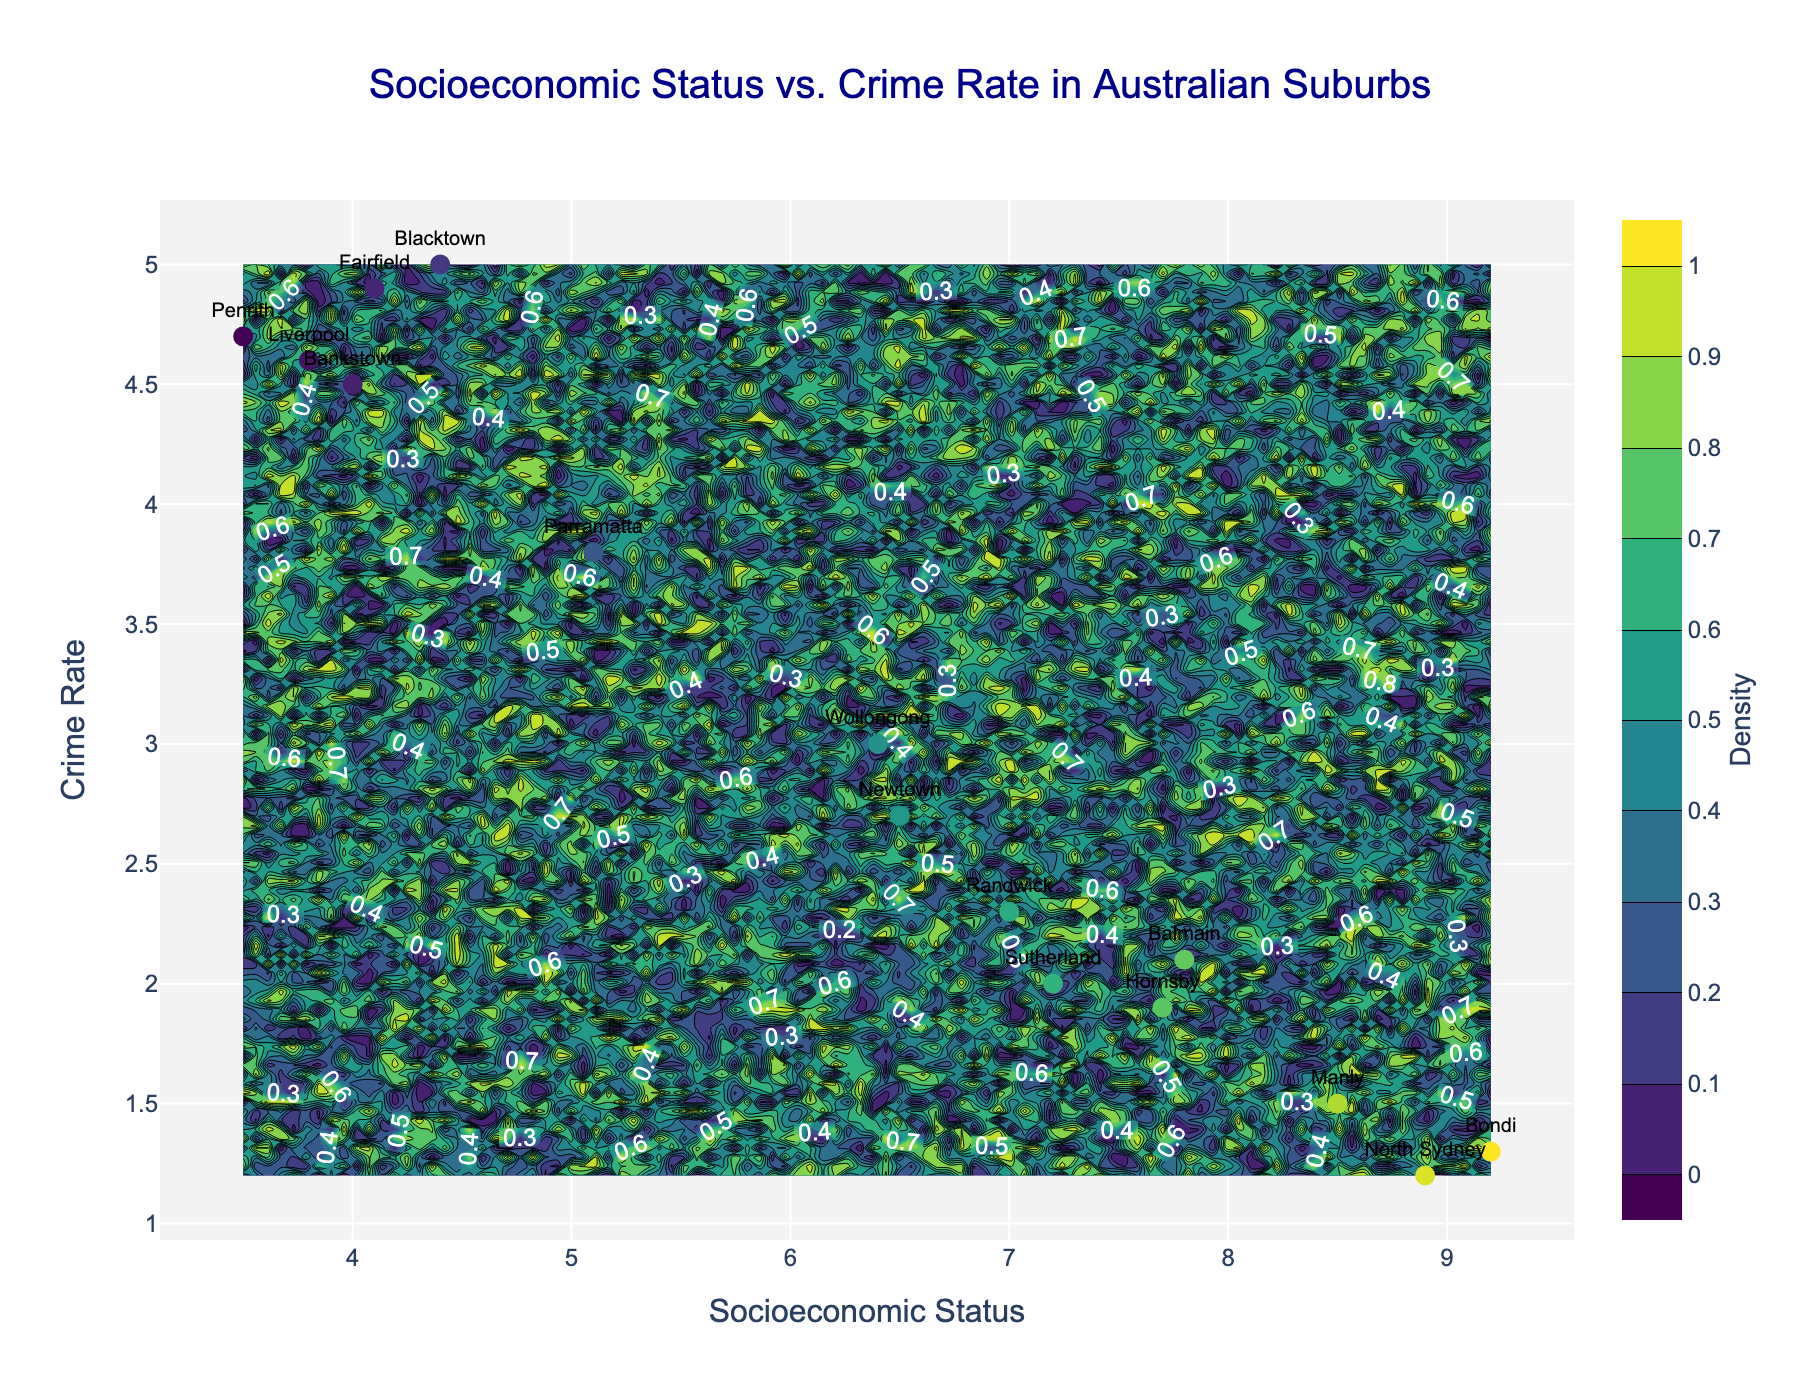What's the title of the figure? The title is prominently displayed at the top of the figure.
Answer: Socioeconomic Status vs. Crime Rate in Australian Suburbs What's the scale used for the color bar in the contour plot? The color bar title and its position are mentioned in the description of the figure.
Answer: Density How many suburbs are labeled on the scatter plot? Each suburb name is labeled and there are 15 suburbs listed in the data provided.
Answer: 15 Which suburb has the highest socioeconomic status and what is its crime rate? By finding the highest Socioeconomic_Status value, we identify Bondi with a value of 9.2 and its corresponding Crime_Rate of 1.3.
Answer: Bondi, 1.3 Which suburb on the plot has the lowest crime rate? The lowest Crime_Rate value in the data is 1.2, which corresponds to North Sydney.
Answer: North Sydney What is the approximate range of socioeconomic status on the contour plot? The minimum and maximum values from the socioeconomic status column are used to determine this.
Answer: 3.5 to 9.2 What is the overall trend of crime rates as socioeconomic status increases across the suburbs? By visually inspecting the scatter plot, it is observed that generally, as socioeconomic status increases, crime rates decrease.
Answer: As socioeconomic status increases, crime rates generally decrease Compare the crime rates of Penrith and Newtown. Which one is higher and by how much? Penrith has a crime rate of 4.7, and Newtown has a crime rate of 2.7. The difference is 4.7 - 2.7 = 2.0.
Answer: Penrith, by 2.0 Identify the suburbs with Socioeconomic_Status greater than 7 that also have a Crime_Rate lower than 2. By filtering through the data, we find that Bondi, Manly, and North Sydney meet both criteria.
Answer: Bondi, Manly, North Sydney Calculate the average crime rate for all the suburbs listed. Sum the crime rates for all suburbs (2.1 + 4.7 + 1.3 + 5.0 + 2.7 + 3.8 + 1.5 + 4.5 + 2.3 + 4.6 + 1.2 + 4.9 + 3.0 + 2.0 + 1.9) and divide by the number of suburbs, which is 15. The total is 45.5, so the average is 45.5 / 15 = 3.03.
Answer: 3.03 